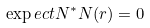Convert formula to latex. <formula><loc_0><loc_0><loc_500><loc_500>\exp e c t { N ^ { * } N } ( r ) = 0</formula> 